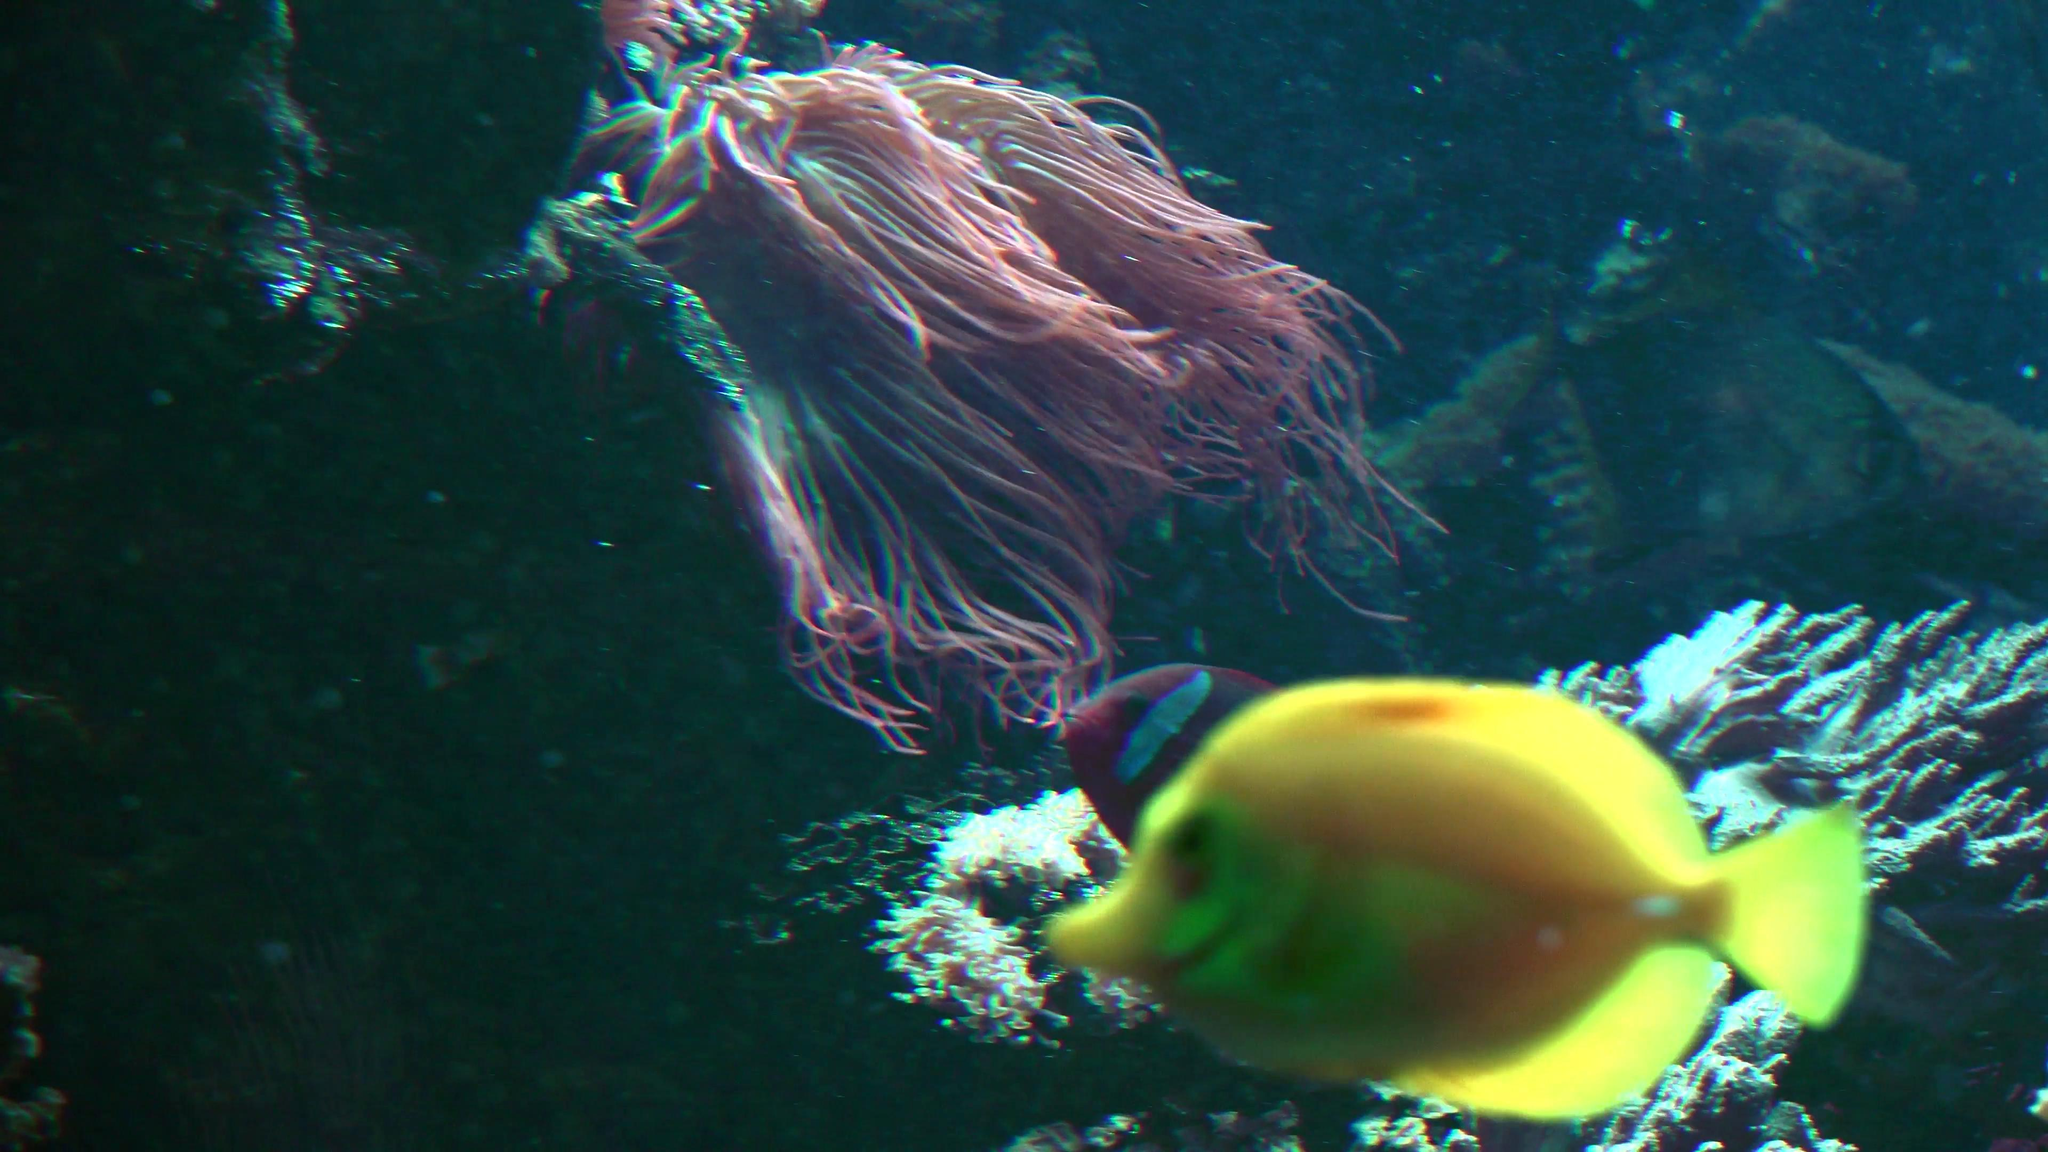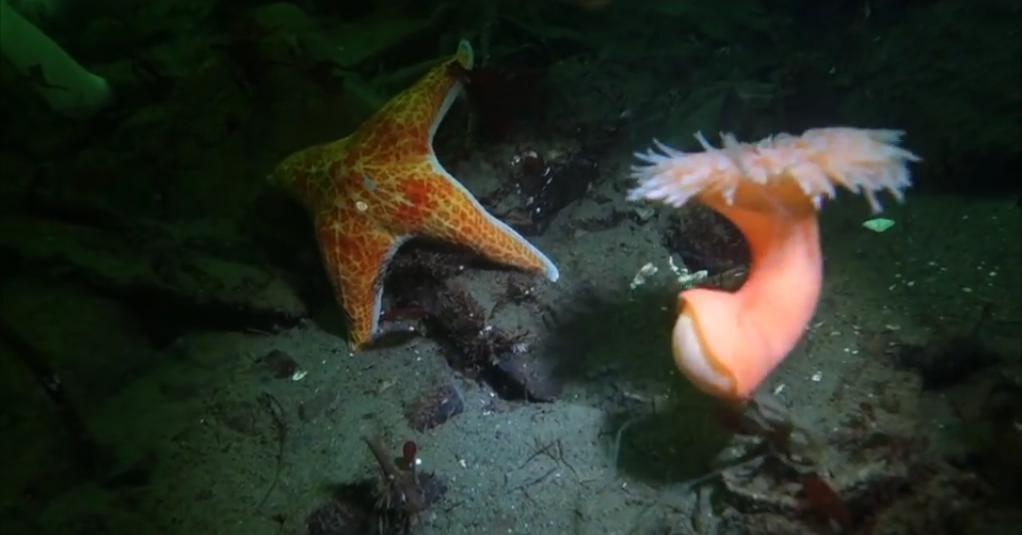The first image is the image on the left, the second image is the image on the right. For the images displayed, is the sentence "In one image in each pair there is a starfish to the left of an anenome." factually correct? Answer yes or no. Yes. The first image is the image on the left, the second image is the image on the right. Analyze the images presented: Is the assertion "The anemone in the left image is orange." valid? Answer yes or no. No. 